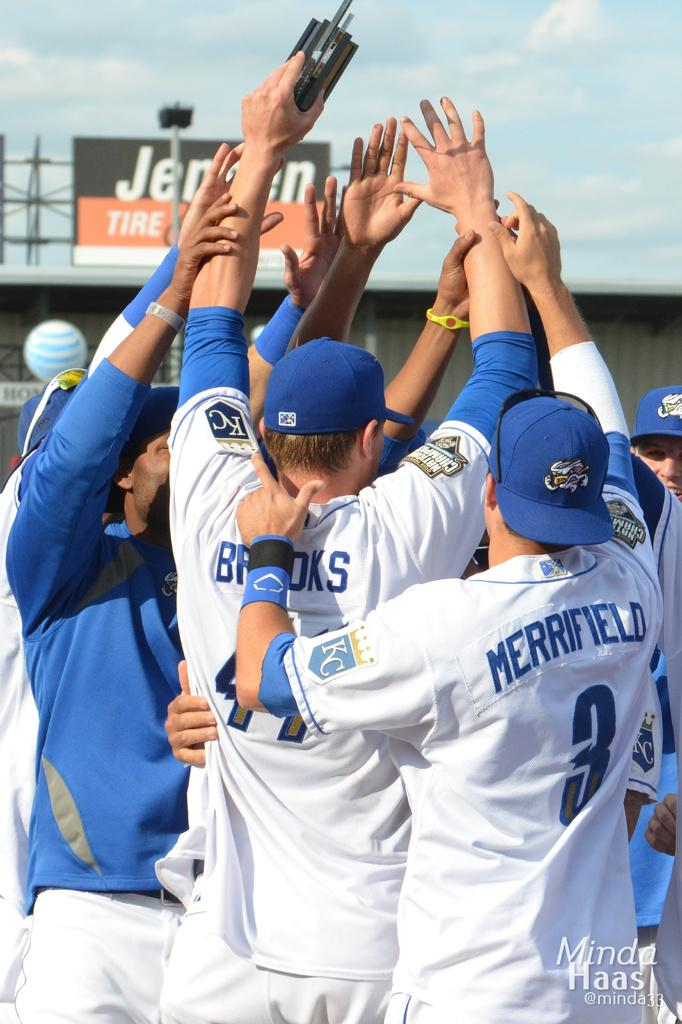Provide a one-sentence caption for the provided image. A baseball team huddled up including Merrifield and Brooks. 